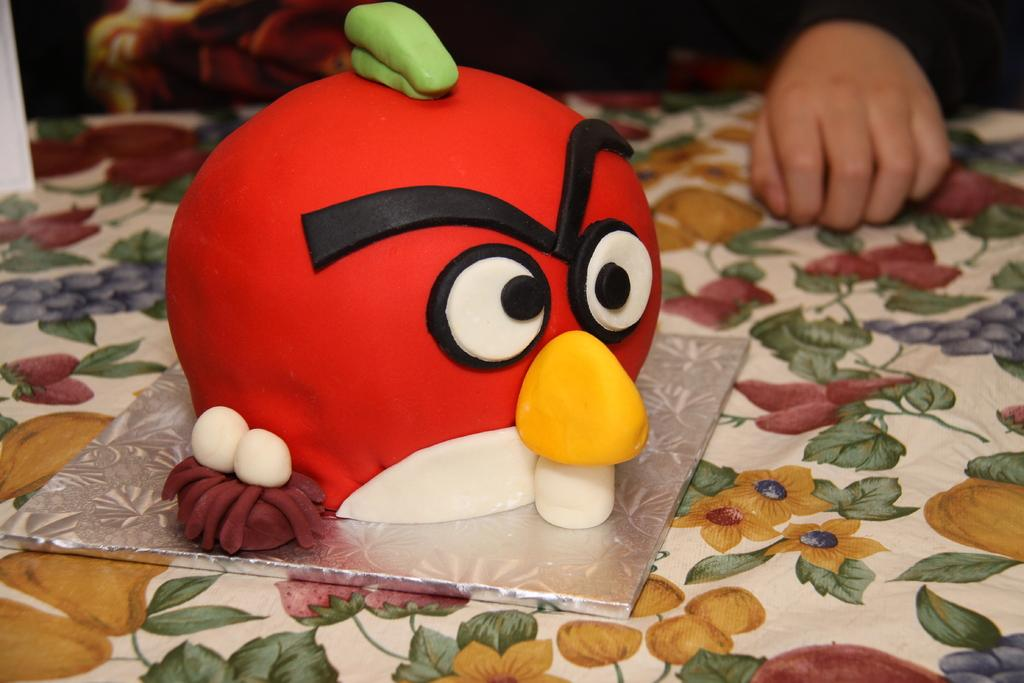What is placed on the bed in the image? There is a cake placed on a bed. Can you describe any other elements in the image? There are persons' hands visible in the background. What type of ray can be seen swimming in the background of the image? There is no ray present in the image; it features a cake on a bed and persons' hands in the background. 